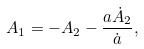<formula> <loc_0><loc_0><loc_500><loc_500>A _ { 1 } = - A _ { 2 } - \frac { a \dot { A } _ { 2 } } { \dot { a } } ,</formula> 